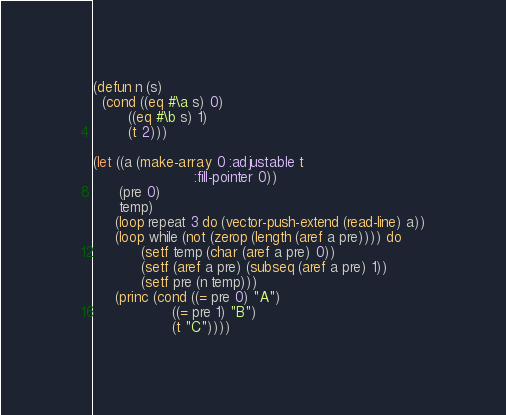Convert code to text. <code><loc_0><loc_0><loc_500><loc_500><_Lisp_>(defun n (s)
  (cond ((eq #\a s) 0)
        ((eq #\b s) 1)
        (t 2)))

(let ((a (make-array 0 :adjustable t
                       :fill-pointer 0))
      (pre 0)
      temp)
     (loop repeat 3 do (vector-push-extend (read-line) a))
     (loop while (not (zerop (length (aref a pre)))) do
           (setf temp (char (aref a pre) 0))
           (setf (aref a pre) (subseq (aref a pre) 1))
           (setf pre (n temp)))
     (princ (cond ((= pre 0) "A")
                  ((= pre 1) "B")
                  (t "C"))))</code> 